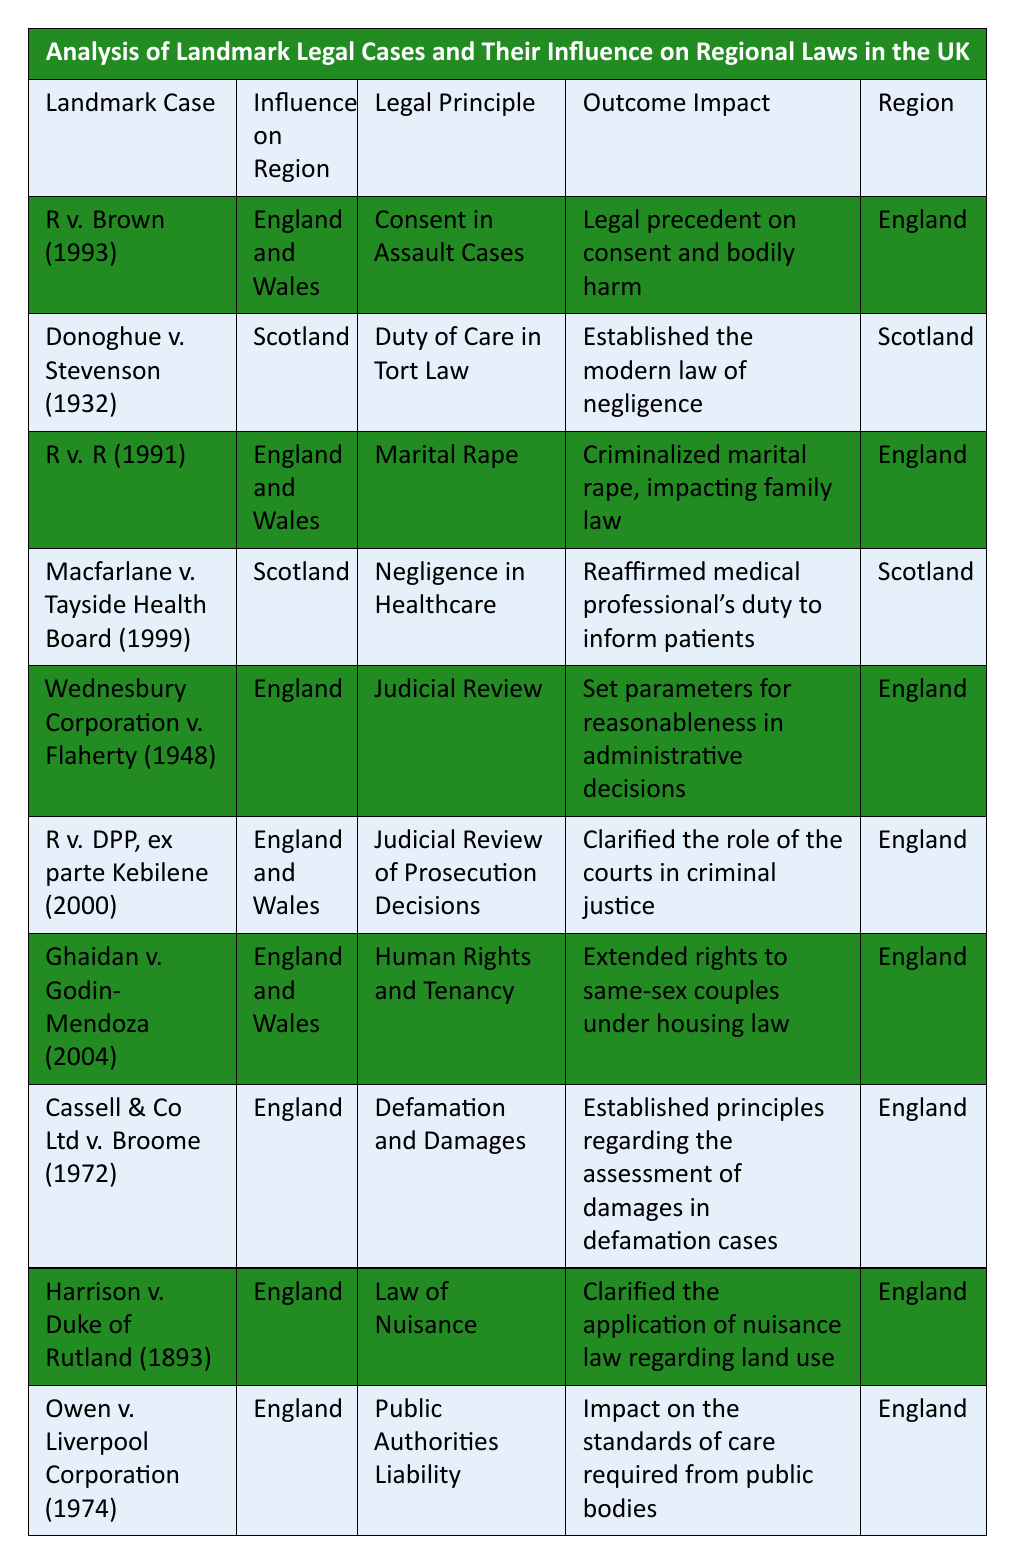What is the legal principle established by R v. Brown (1993)? In the table, R v. Brown (1993) has "Consent in Assault Cases" listed under the Legal Principle column.
Answer: Consent in Assault Cases Which landmark case has influenced the region of Scotland? The table includes two cases influencing Scotland: Donoghue v. Stevenson (1932) and Macfarlane v. Tayside Health Board (1999).
Answer: Donoghue v. Stevenson (1932) and Macfarlane v. Tayside Health Board (1999) Is R v. R (1991) related to family law? The Outcome Impact for R v. R (1991) states "Criminalized marital rape, impacting family law," indicating its relevance to family law.
Answer: Yes How many cases refer specifically to judicial review? The table lists Wednesbury Corporation v. Flaherty (1948) and R v. DPP, ex parte Kebilene (2000) as relating to judicial review; therefore, there are two such cases.
Answer: 2 Which case established the modern law of negligence? According to the table, Donoghue v. Stevenson (1932) is noted for "Established the modern law of negligence" in the Outcome Impact column.
Answer: Donoghue v. Stevenson (1932) What is the outcome impact of Ghaidan v. Godin-Mendoza (2004)? The table states that Ghaidan v. Godin-Mendoza (2004) extended rights to same-sex couples under housing law, thus identifying its impact.
Answer: Extended rights to same-sex couples under housing law Which region is influenced by both R v. DPP, ex parte Kebilene (2000) and R v. R (1991)? The table shows that both R v. DPP, ex parte Kebilene (2000) and R v. R (1991) influence "England and Wales" as mentioned in the Influence on Region column.
Answer: England and Wales How many cases specifically impact English law? All cases except Donoghue v. Stevenson (1932) and Macfarlane v. Tayside Health Board (1999) reference English law; counting these yields seven cases.
Answer: 7 In which year was the case concerning public authorities' liability decided? The table indicates that Owen v. Liverpool Corporation, which addresses public authorities' liability, was decided in 1974, as stated in the Landmark Case column.
Answer: 1974 